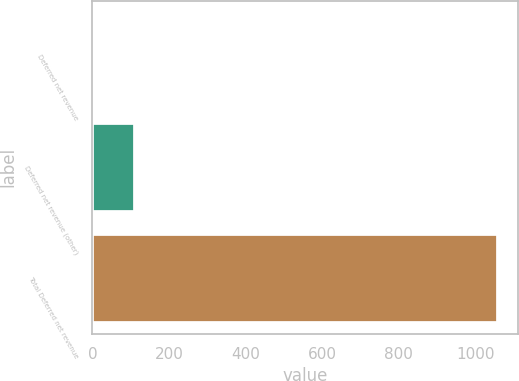Convert chart to OTSL. <chart><loc_0><loc_0><loc_500><loc_500><bar_chart><fcel>Deferred net revenue<fcel>Deferred net revenue (other)<fcel>Total Deferred net revenue<nl><fcel>5<fcel>110.4<fcel>1059<nl></chart> 